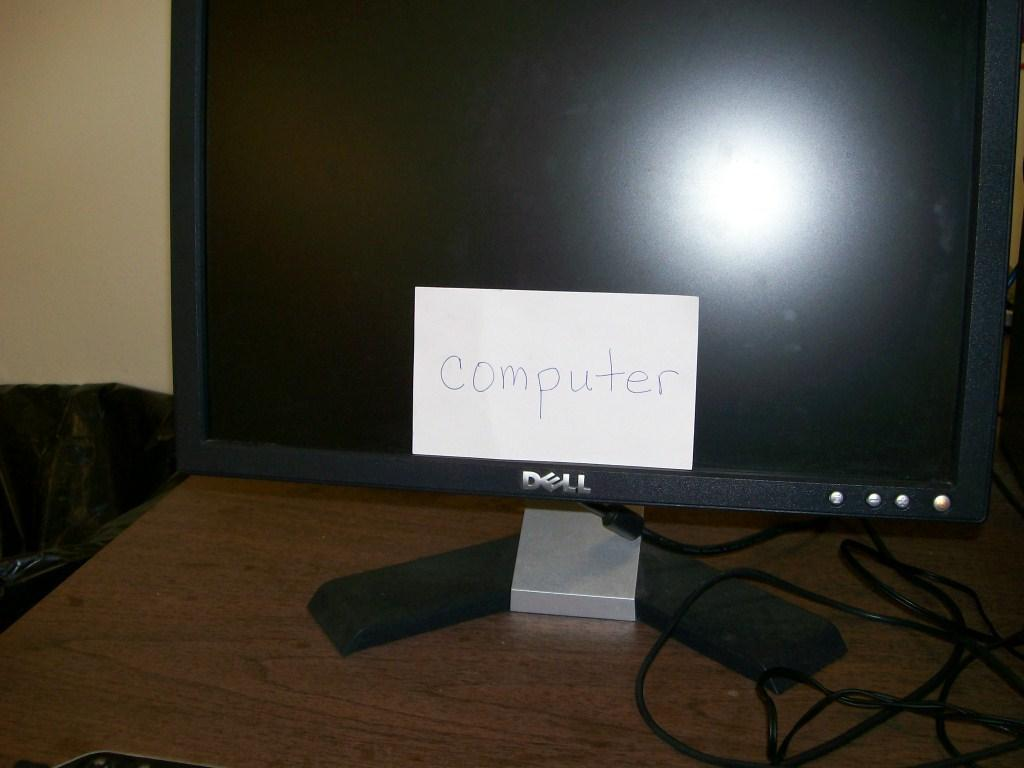<image>
Describe the image concisely. A Dell monitor with a white paper with computer written on it 